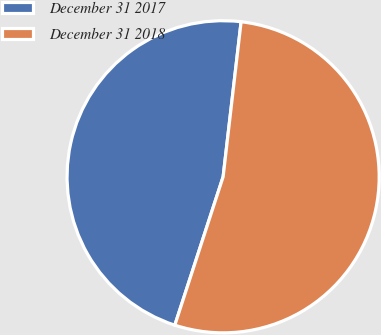Convert chart. <chart><loc_0><loc_0><loc_500><loc_500><pie_chart><fcel>December 31 2017<fcel>December 31 2018<nl><fcel>46.83%<fcel>53.17%<nl></chart> 